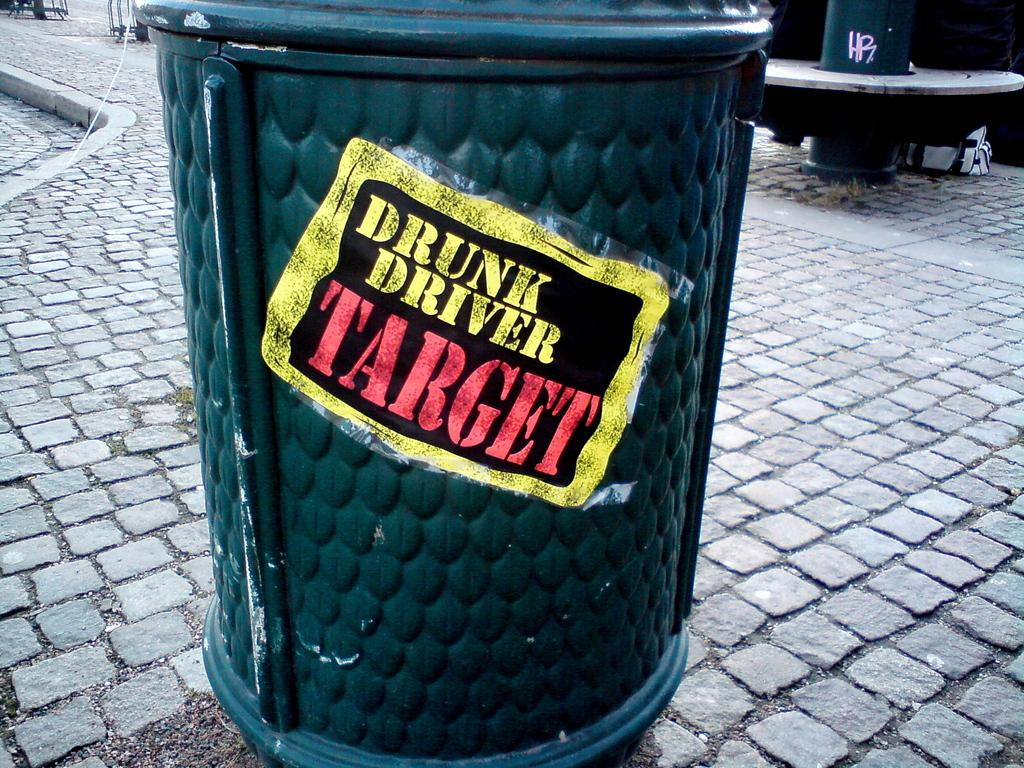<image>
Provide a brief description of the given image. A sign on a trash can says it is a drunk driver target. 